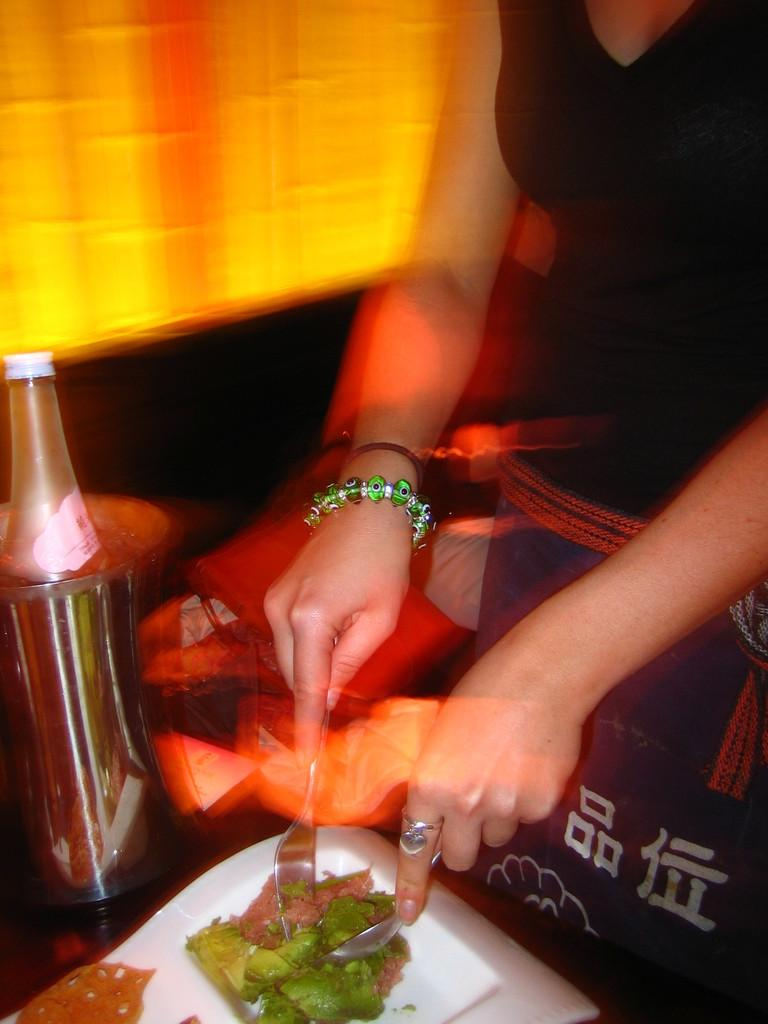What is the person in the image holding? The person is holding a spoon and a fork in the image. What is on the plate that the person might be eating? There is food on a plate in the image. What can be seen on the table in the image? There is a bottle on a table in the image. What type of furniture is in the image? There is a couch with a pillow in the image. What type of watch is the farmer wearing in the image? There is no farmer or watch present in the image. What kind of toy can be seen on the couch in the image? There is no toy present on the couch in the image; only a pillow is visible. 